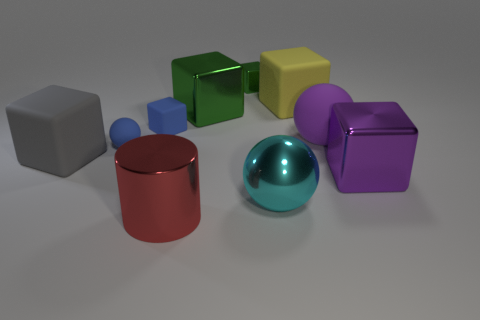What color is the rubber cube that is both to the left of the small green metal thing and to the right of the gray object?
Your answer should be very brief. Blue. Are the purple sphere and the red cylinder made of the same material?
Your answer should be very brief. No. What shape is the big gray matte object?
Your response must be concise. Cube. There is a big ball in front of the big rubber block that is in front of the yellow rubber thing; what number of large cubes are to the right of it?
Offer a terse response. 2. There is a small matte object that is the same shape as the big cyan metallic object; what color is it?
Give a very brief answer. Blue. There is a small blue rubber thing that is in front of the big sphere behind the big cyan metallic thing that is on the right side of the small blue matte block; what shape is it?
Your answer should be very brief. Sphere. There is a matte thing that is left of the metal ball and behind the tiny ball; what size is it?
Provide a succinct answer. Small. Is the number of tiny blue rubber objects less than the number of metal cubes?
Keep it short and to the point. Yes. How big is the rubber sphere left of the small green thing?
Offer a very short reply. Small. There is a large thing that is behind the big rubber ball and on the left side of the cyan object; what is its shape?
Keep it short and to the point. Cube. 